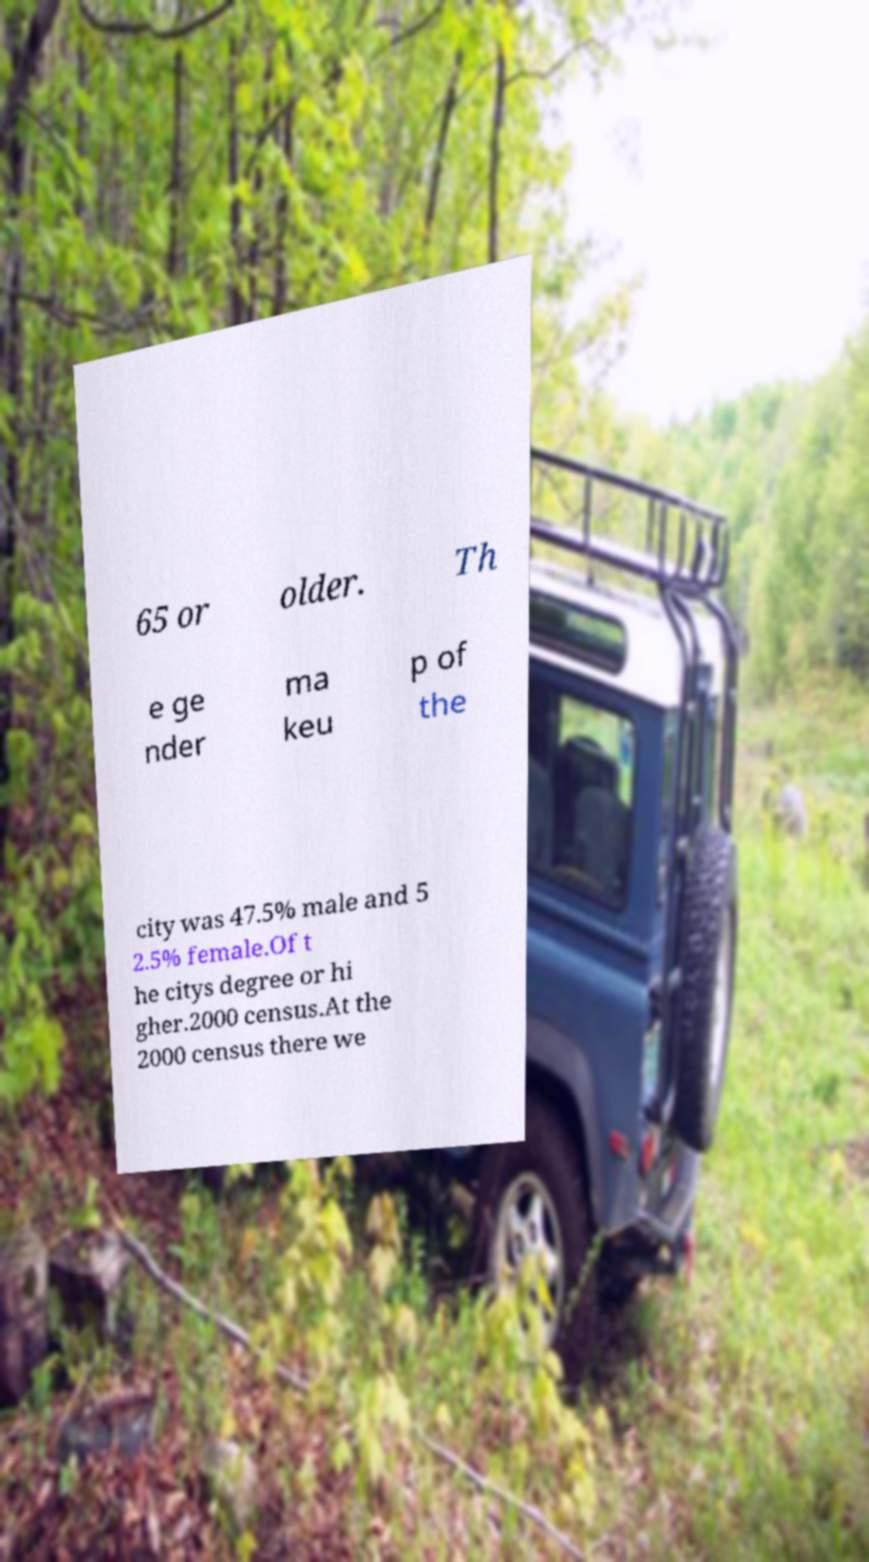Please identify and transcribe the text found in this image. 65 or older. Th e ge nder ma keu p of the city was 47.5% male and 5 2.5% female.Of t he citys degree or hi gher.2000 census.At the 2000 census there we 